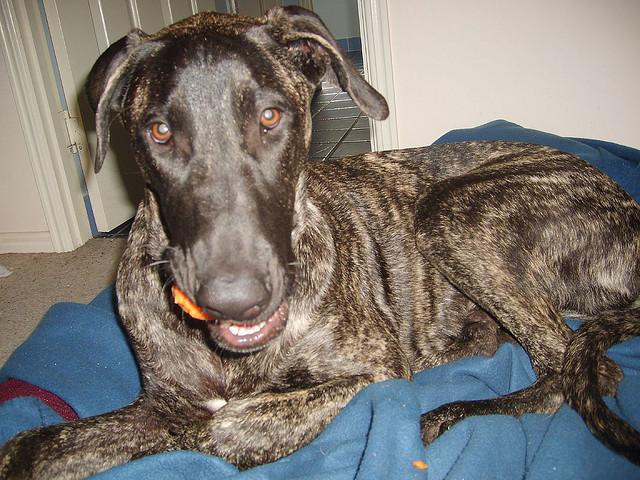What color are the dogs eyes?
Answer briefly. Brown. What color is the blanket?
Give a very brief answer. Blue. What breed of dog is this?
Quick response, please. Lab. 